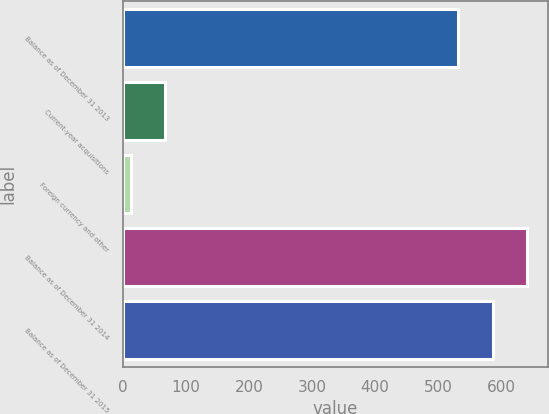Convert chart. <chart><loc_0><loc_0><loc_500><loc_500><bar_chart><fcel>Balance as of December 31 2013<fcel>Current-year acquisitions<fcel>Foreign currency and other<fcel>Balance as of December 31 2014<fcel>Balance as of December 31 2015<nl><fcel>532<fcel>67.05<fcel>12.2<fcel>641.7<fcel>586.85<nl></chart> 